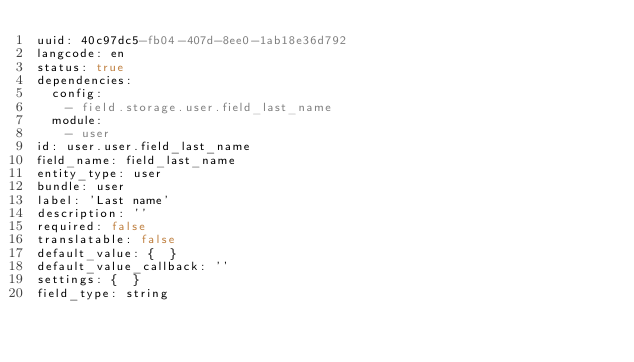<code> <loc_0><loc_0><loc_500><loc_500><_YAML_>uuid: 40c97dc5-fb04-407d-8ee0-1ab18e36d792
langcode: en
status: true
dependencies:
  config:
    - field.storage.user.field_last_name
  module:
    - user
id: user.user.field_last_name
field_name: field_last_name
entity_type: user
bundle: user
label: 'Last name'
description: ''
required: false
translatable: false
default_value: {  }
default_value_callback: ''
settings: {  }
field_type: string
</code> 